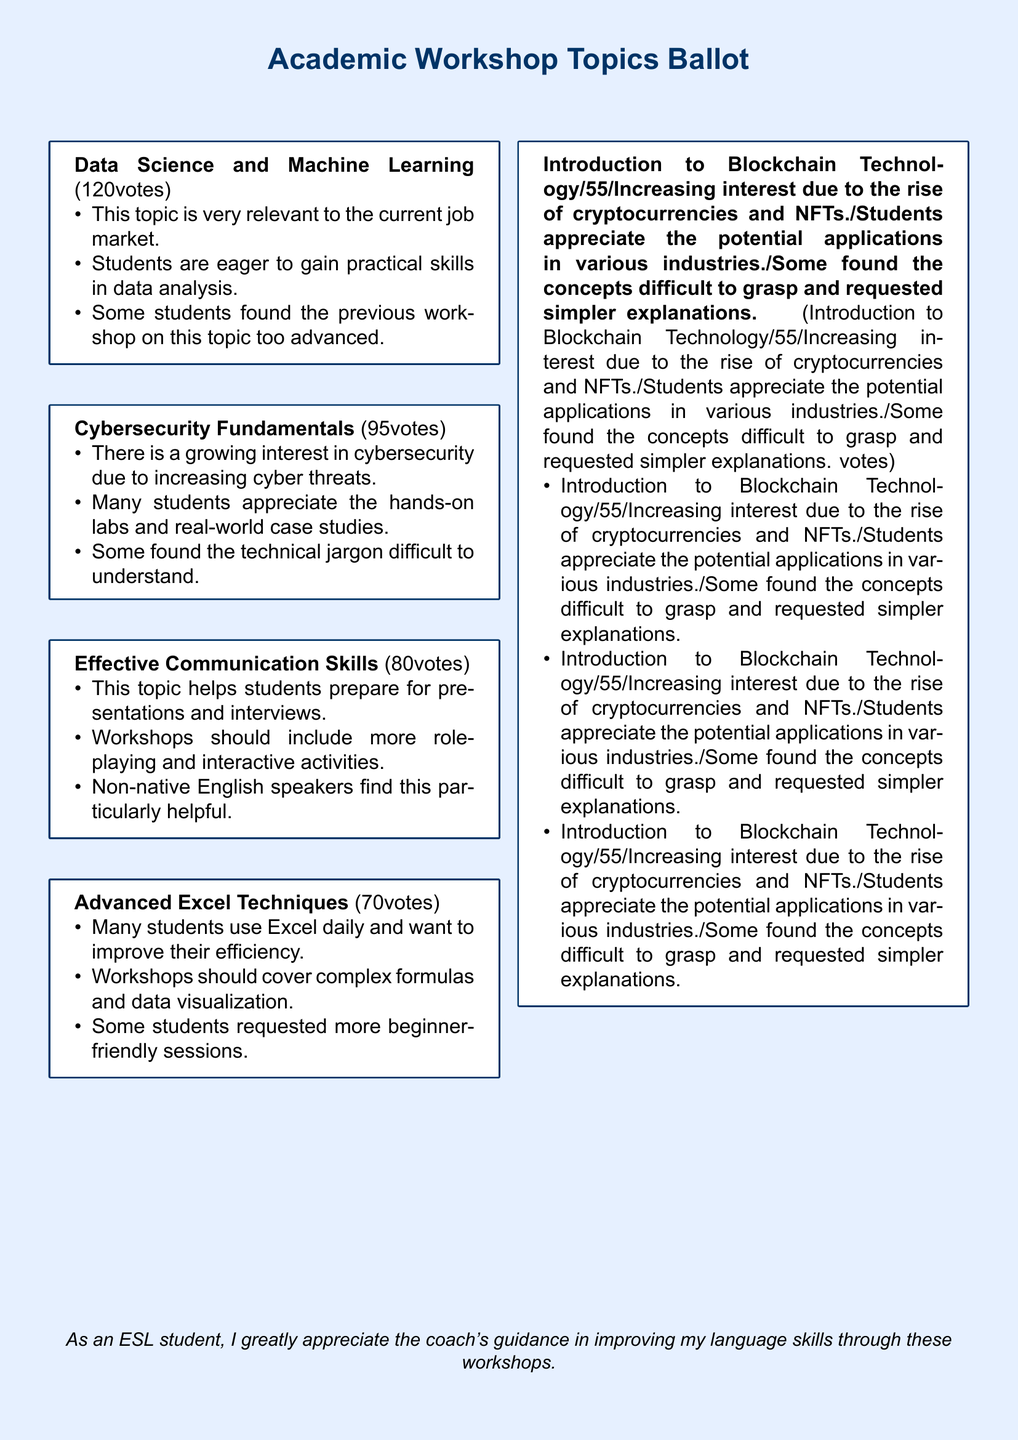What is the topic with the highest number of votes? The topic with the highest number of votes is Data Science and Machine Learning, which received 120 votes.
Answer: Data Science and Machine Learning How many votes did the topic Cybersecurity Fundamentals receive? Cybersecurity Fundamentals received 95 votes, as stated in the document.
Answer: 95 What feedback was given regarding Effective Communication Skills? The feedback includes that workshops should include more role-playing and interactive activities.
Answer: Workshops should include more role-playing and interactive activities Which workshop topic had the lowest number of votes? Introduction to Blockchain Technology had the lowest number of votes with 55 votes.
Answer: Introduction to Blockchain Technology What percentage of students provided feedback on Advanced Excel Techniques? The document does not specify the percentage of students who provided feedback on this topic, but it does include three feedback points related to it.
Answer: Not specified Which topic is noted for being particularly helpful for non-native English speakers? The topic Effective Communication Skills is noted for being particularly helpful for non-native English speakers.
Answer: Effective Communication Skills What was a common student request for the workshop on Advanced Excel Techniques? Students requested more beginner-friendly sessions for the Advanced Excel Techniques workshop.
Answer: More beginner-friendly sessions How many feedback points were listed for each topic? There are three feedback points provided for each topic, highlighting different student perspectives.
Answer: Three What was the overarching sentiment expressed by the ESL student in the document? The ESL student greatly appreciates the coach's guidance in improving their language skills through these workshops.
Answer: Appreciates the coach's guidance 